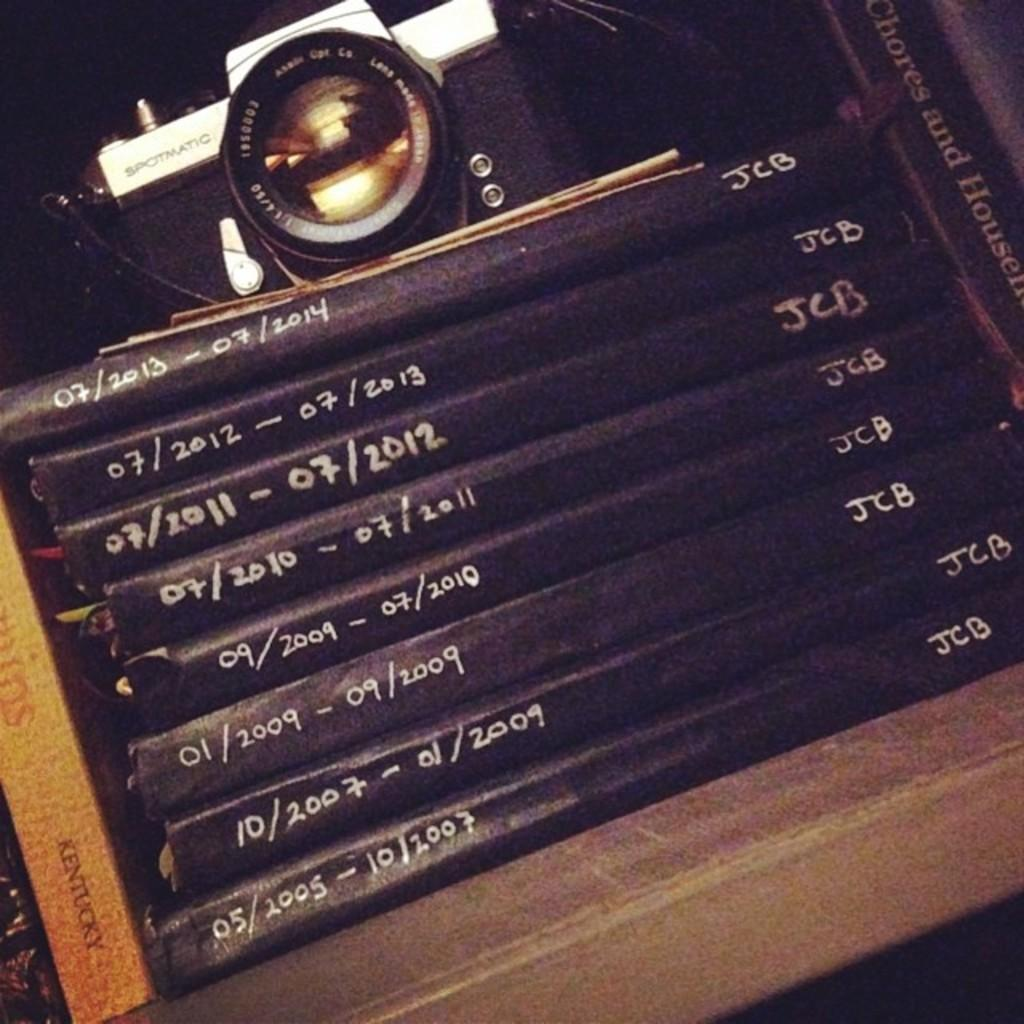<image>
Write a terse but informative summary of the picture. White and black camera which says SPOTMATIC on it on top of some books. 